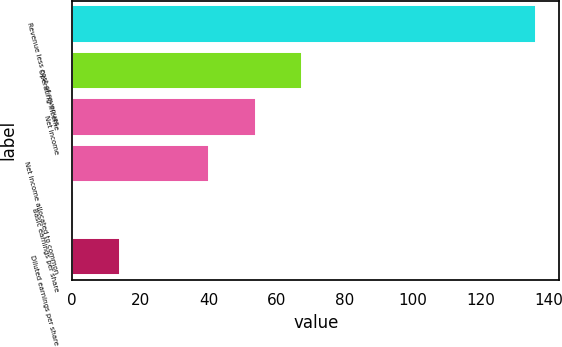Convert chart. <chart><loc_0><loc_0><loc_500><loc_500><bar_chart><fcel>Revenue less cost of revenues<fcel>Operating income<fcel>Net income<fcel>Net income allocated to common<fcel>Basic earnings per share<fcel>Diluted earnings per share<nl><fcel>136.2<fcel>67.44<fcel>53.87<fcel>40.3<fcel>0.5<fcel>14.07<nl></chart> 